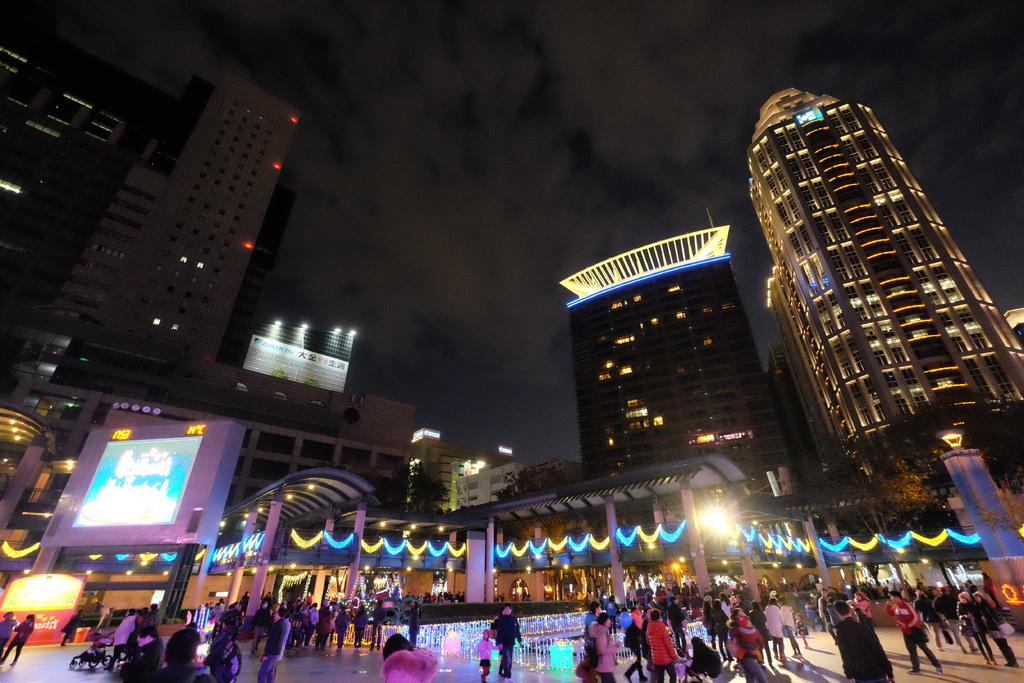What type of structures can be seen in the image? There are buildings in the image. What are the people in the image doing? There are people walking in the image. What is being displayed on the screen in the image? The screen in the image is displaying something, but we cannot determine what it is from the provided facts. What can be seen illuminated in the image? There are lights visible in the image. What is written on the hoarding in the image? There is a hoarding with text in the image, but we cannot determine the specific text from the provided facts. What is visible in the sky in the image? The sky is visible in the image. How many potatoes are being gripped by the people walking in the image? There is no mention of potatoes or gripping in the image, so we cannot answer this question. 